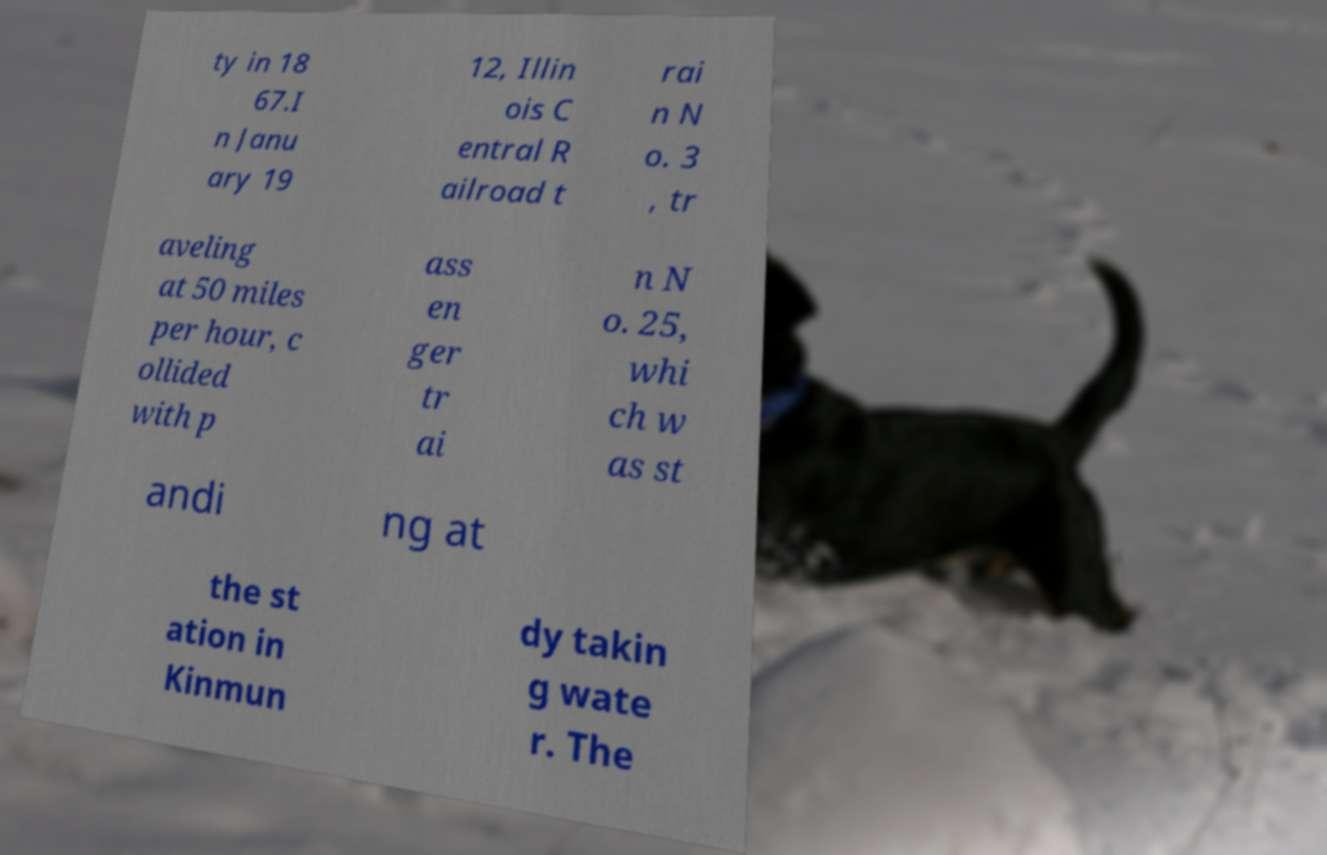Can you read and provide the text displayed in the image?This photo seems to have some interesting text. Can you extract and type it out for me? ty in 18 67.I n Janu ary 19 12, Illin ois C entral R ailroad t rai n N o. 3 , tr aveling at 50 miles per hour, c ollided with p ass en ger tr ai n N o. 25, whi ch w as st andi ng at the st ation in Kinmun dy takin g wate r. The 